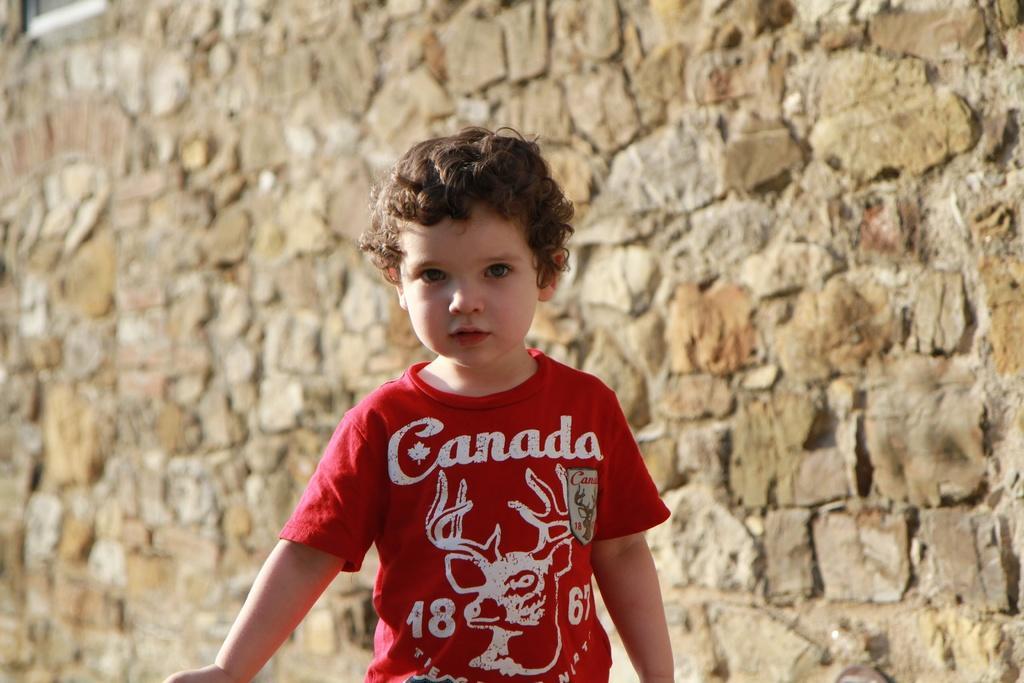Describe this image in one or two sentences. In this picture, it seems like a small boy in the foreground and a wall in the background. 